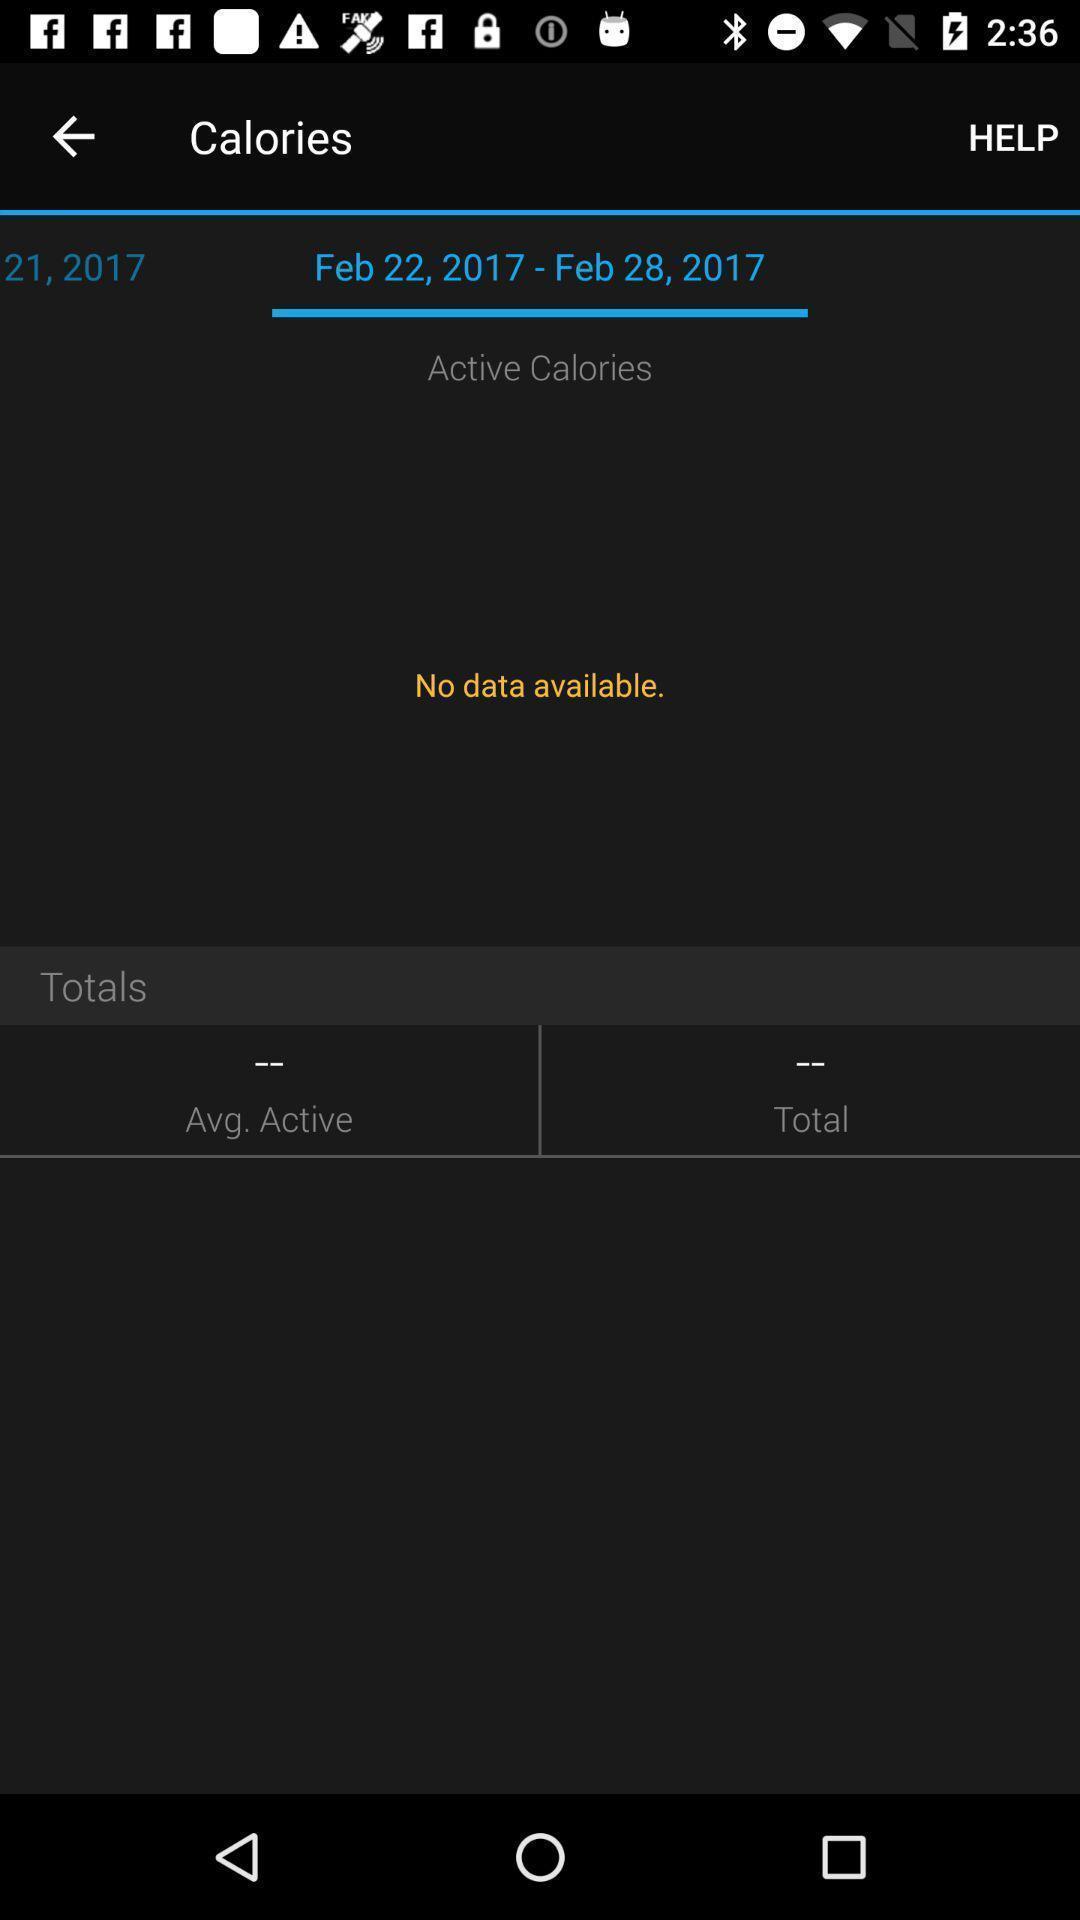Provide a detailed account of this screenshot. Screen showing calories page of app. 